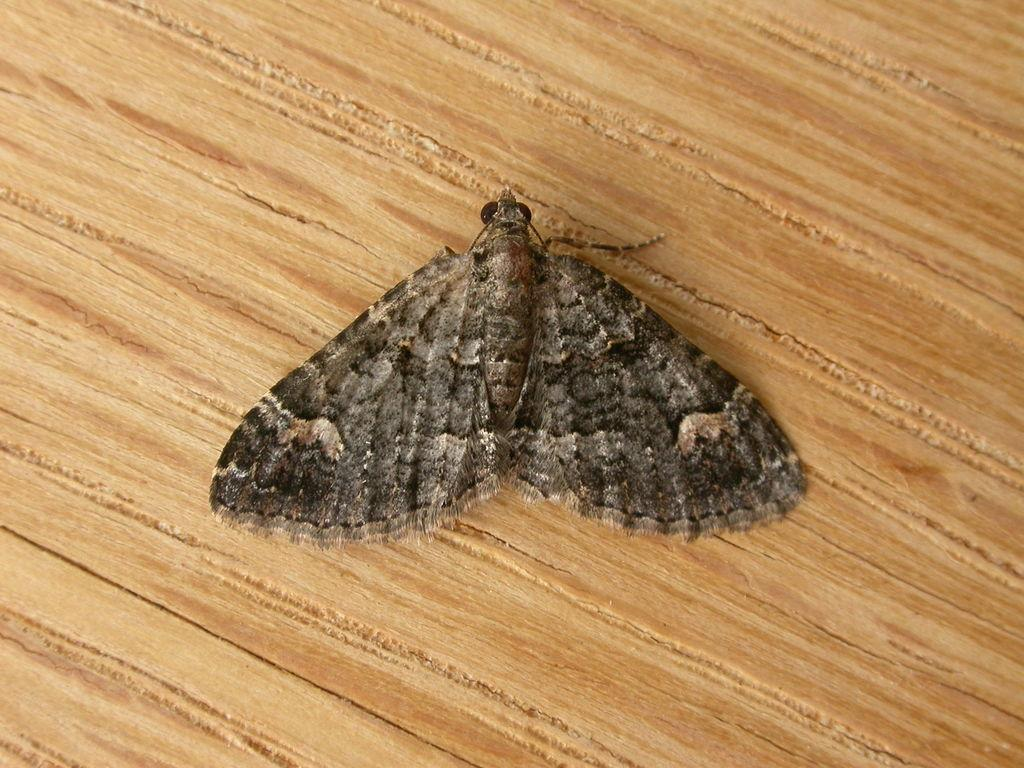What is the main subject of the image? There is a butterfly in the image. What type of surface is the butterfly on? The butterfly is on a wooden surface. What type of leaf is the butterfly sitting on in the image? There is no leaf present in the image; the butterfly is on a wooden surface. What historical event is depicted in the image? There is no historical event depicted in the image; it features a butterfly on a wooden surface. 